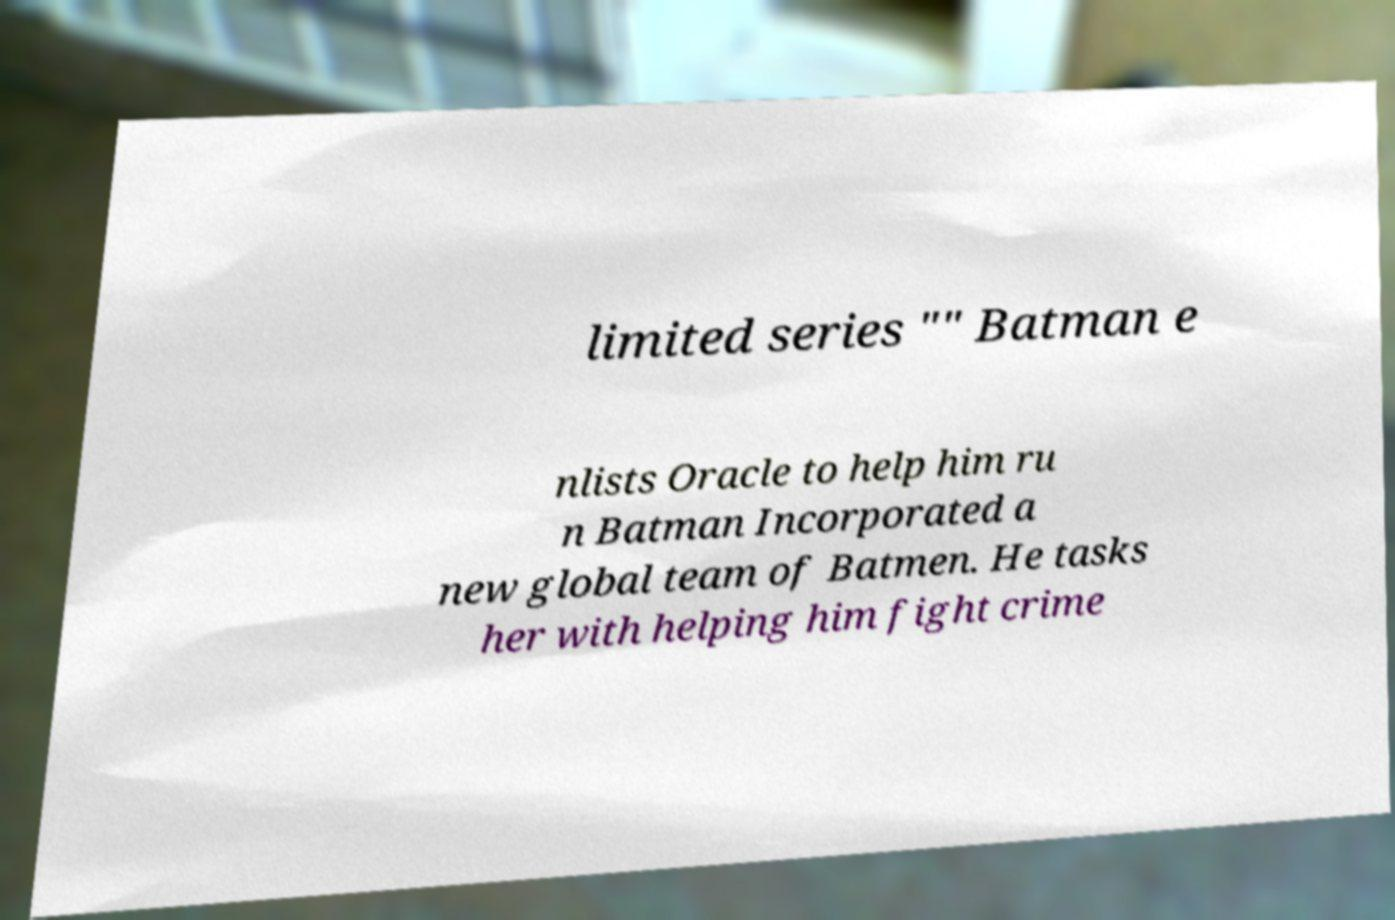Can you read and provide the text displayed in the image?This photo seems to have some interesting text. Can you extract and type it out for me? limited series "" Batman e nlists Oracle to help him ru n Batman Incorporated a new global team of Batmen. He tasks her with helping him fight crime 